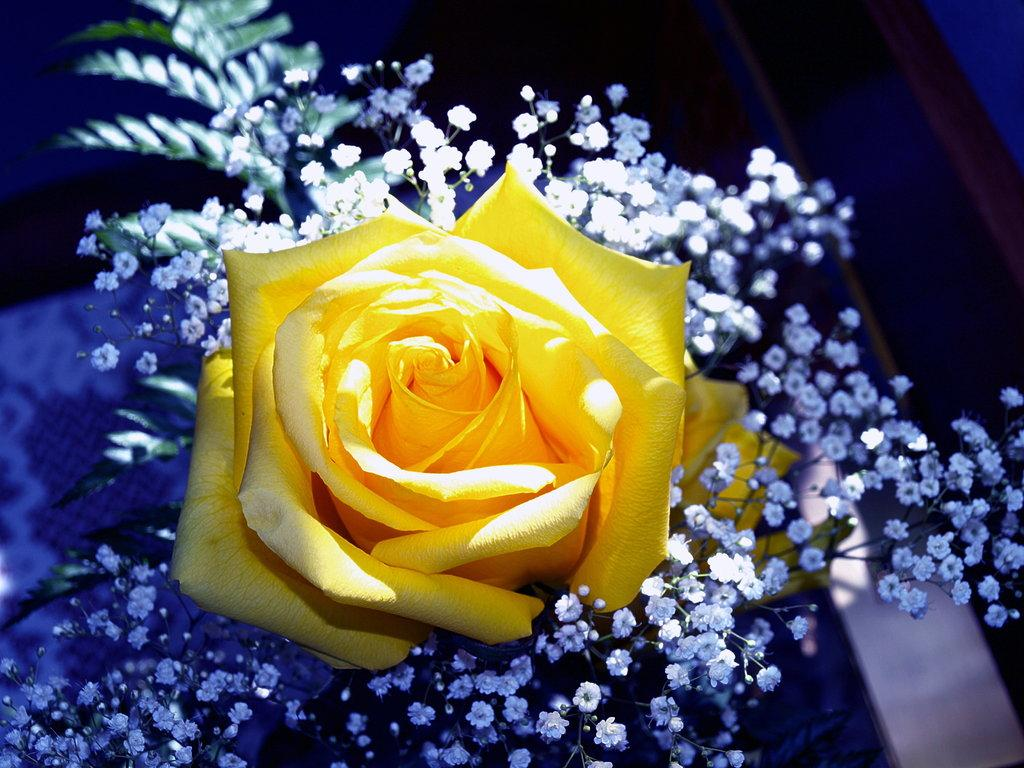What is the main subject of the image? There is a yellow color rose in the center of the image. Are there any other flowers present in the image? Yes, there are other flowers in the image. What type of card is being used to represent the hobbies of the person in the image? There is no card or representation of hobbies present in the image; it primarily features flowers. 